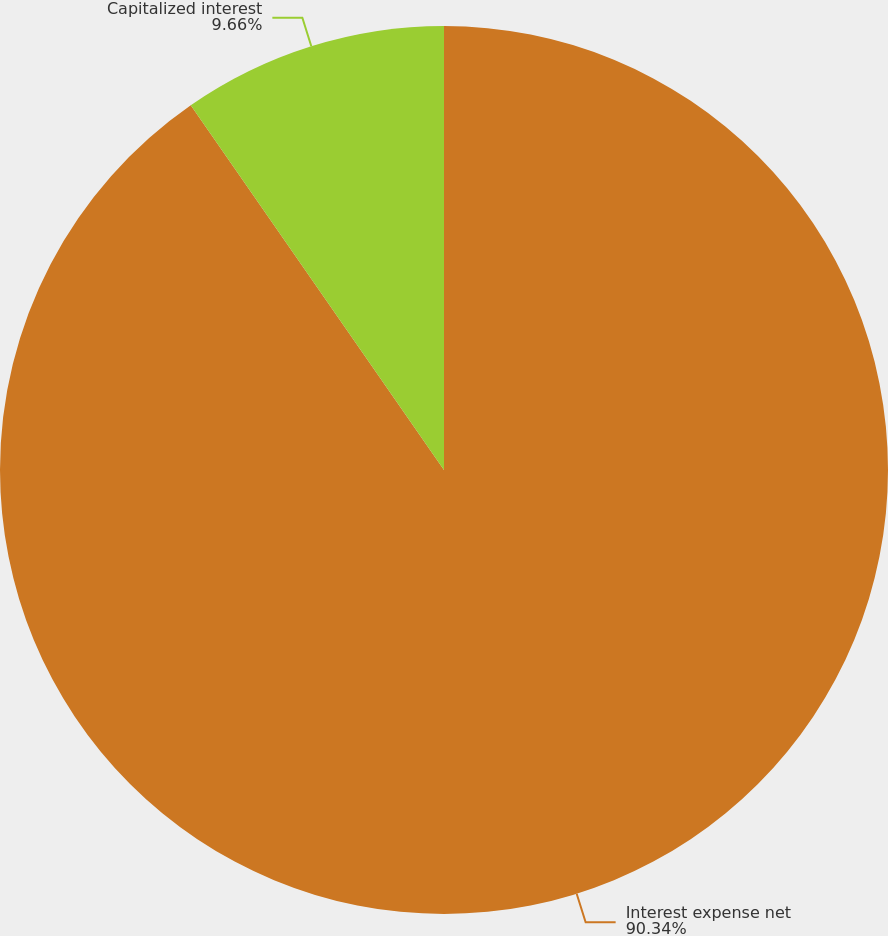Convert chart to OTSL. <chart><loc_0><loc_0><loc_500><loc_500><pie_chart><fcel>Interest expense net<fcel>Capitalized interest<nl><fcel>90.34%<fcel>9.66%<nl></chart> 